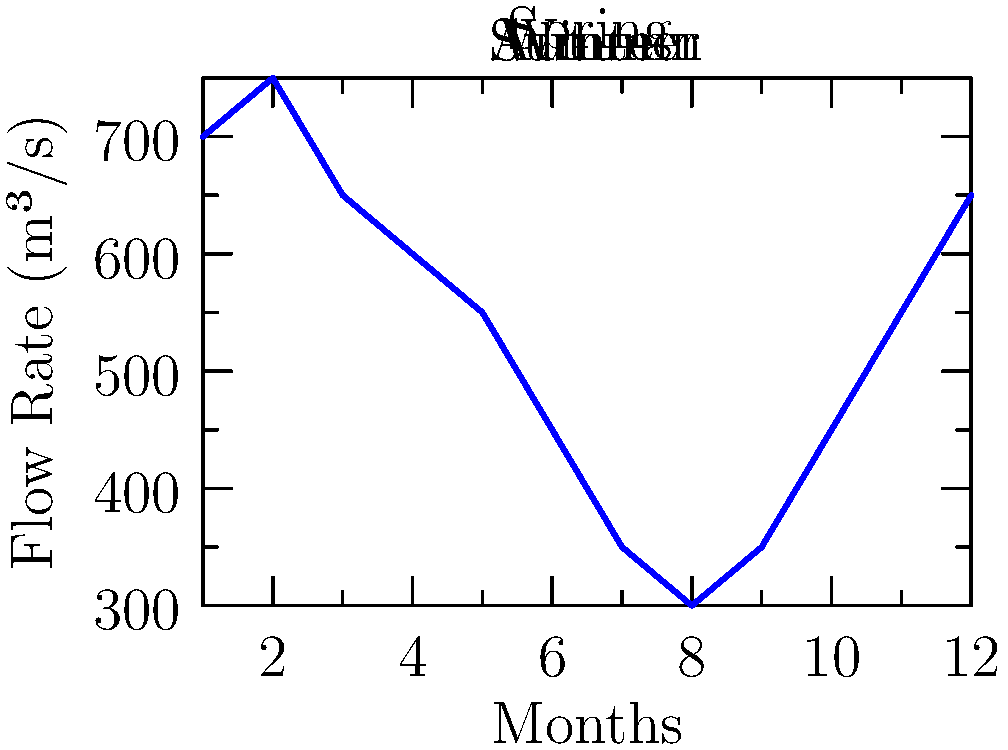As a saxophonist who frequently performs by the Seine, you've noticed changes in the river's flow throughout the year. Using the graph of the Seine's average monthly flow rates, calculate the difference in flow rate between the highest (February) and lowest (August) months. How might this variation affect your performances? To solve this problem, we'll follow these steps:

1. Identify the highest flow rate (February):
   From the graph, we can see that February has the highest flow rate at 750 m³/s.

2. Identify the lowest flow rate (August):
   The graph shows August has the lowest flow rate at 300 m³/s.

3. Calculate the difference:
   $$\text{Difference} = \text{February flow rate} - \text{August flow rate}$$
   $$\text{Difference} = 750 \text{ m³/s} - 300 \text{ m³/s} = 450 \text{ m³/s}$$

4. Consider the impact on performances:
   - Higher flow rates in winter (February) might create more background noise, potentially requiring you to play louder or use amplification.
   - Lower flow rates in summer (August) could mean a calmer river, allowing for softer, more nuanced performances.
   - The variation in flow rates might also affect the number of people visiting the Seine, influencing your audience size.
   - Different flow rates could change the river's ambiance, inspiring varied musical moods throughout the year.
Answer: 450 m³/s; affects performance volume and ambiance 